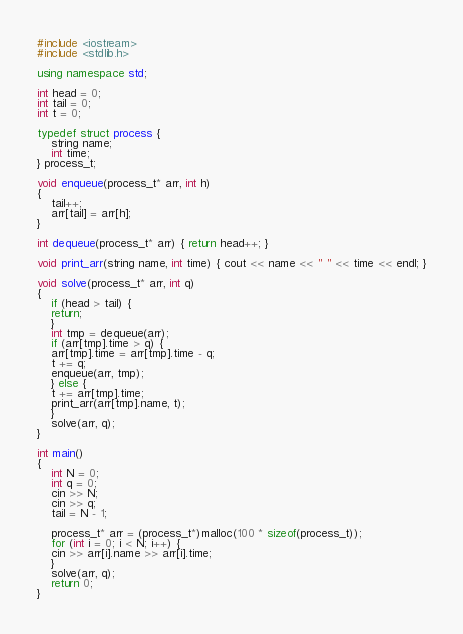Convert code to text. <code><loc_0><loc_0><loc_500><loc_500><_C++_>#include <iostream>
#include <stdlib.h>

using namespace std;

int head = 0;
int tail = 0;
int t = 0;

typedef struct process {
    string name;
    int time;
} process_t;

void enqueue(process_t* arr, int h)
{
    tail++;
    arr[tail] = arr[h];
}

int dequeue(process_t* arr) { return head++; }

void print_arr(string name, int time) { cout << name << " " << time << endl; }

void solve(process_t* arr, int q)
{
    if (head > tail) {
	return;
    }
    int tmp = dequeue(arr);
    if (arr[tmp].time > q) {
	arr[tmp].time = arr[tmp].time - q;
	t += q;
	enqueue(arr, tmp);
    } else {
	t += arr[tmp].time;
	print_arr(arr[tmp].name, t);
    }
    solve(arr, q);
}

int main()
{
    int N = 0;
    int q = 0;
    cin >> N;
    cin >> q;
    tail = N - 1;

    process_t* arr = (process_t*)malloc(100 * sizeof(process_t));
    for (int i = 0; i < N; i++) {
	cin >> arr[i].name >> arr[i].time;
    }
    solve(arr, q);
    return 0;
}</code> 